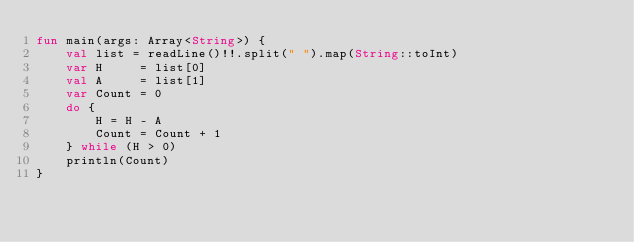<code> <loc_0><loc_0><loc_500><loc_500><_Kotlin_>fun main(args: Array<String>) {
    val list = readLine()!!.split(" ").map(String::toInt)
    var H     = list[0]
    val A     = list[1]
    var Count = 0
    do {
        H = H - A
        Count = Count + 1
    } while (H > 0)
    println(Count)
}</code> 